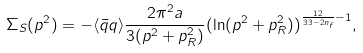Convert formula to latex. <formula><loc_0><loc_0><loc_500><loc_500>\Sigma _ { S } ( p ^ { 2 } ) = - \langle { \bar { q } } q \rangle \frac { 2 \pi ^ { 2 } a } { 3 ( p ^ { 2 } + p _ { R } ^ { 2 } ) } ( \ln ( p ^ { 2 } + p _ { R } ^ { 2 } ) ) ^ { \frac { 1 2 } { 3 3 - 2 n _ { f } } - 1 } ,</formula> 